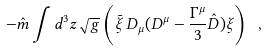Convert formula to latex. <formula><loc_0><loc_0><loc_500><loc_500>- \hat { m } \int d ^ { 3 } z \sqrt { g } \left ( \bar { \xi } \, D _ { \mu } ( D ^ { \mu } - \frac { \Gamma ^ { \mu } } { 3 } \hat { D } ) \xi \right ) \ ,</formula> 